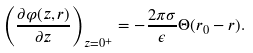<formula> <loc_0><loc_0><loc_500><loc_500>\left ( \frac { \partial \varphi ( z , r ) } { \partial z } \right ) _ { z = 0 ^ { + } } = - \frac { 2 \pi \sigma } { \epsilon } \Theta ( r _ { 0 } - r ) .</formula> 